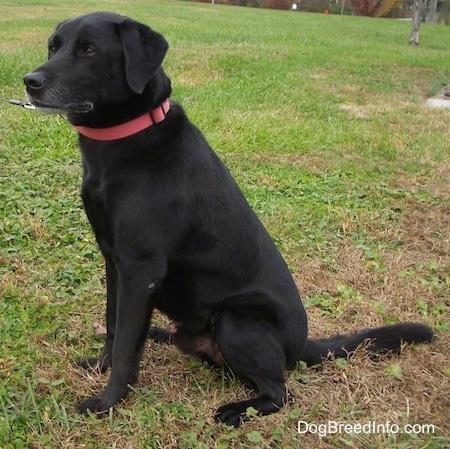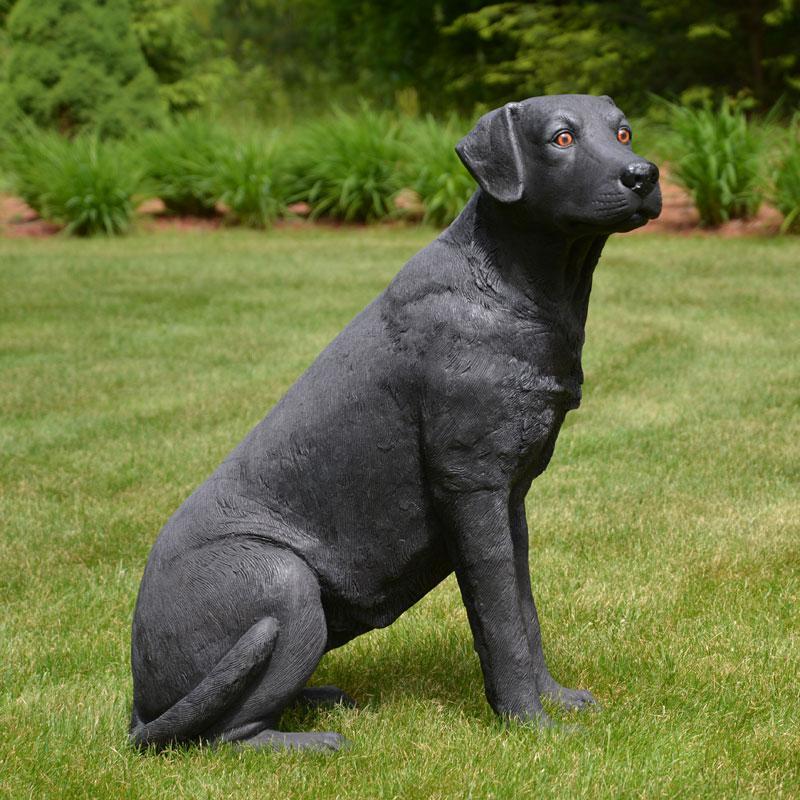The first image is the image on the left, the second image is the image on the right. Assess this claim about the two images: "A dog is standing and facing left.". Correct or not? Answer yes or no. No. 